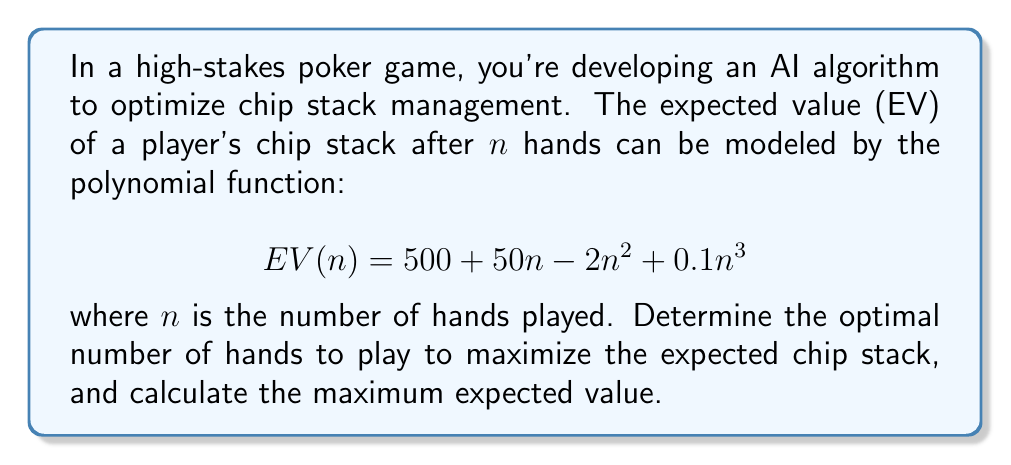Provide a solution to this math problem. To solve this optimization problem, we need to find the maximum of the polynomial function $EV(n)$. This can be done by finding the point where the first derivative of $EV(n)$ equals zero and the second derivative is negative.

1. First, let's find the first derivative of $EV(n)$:
   $$EV'(n) = 50 - 4n + 0.3n^2$$

2. Set the first derivative to zero and solve for n:
   $$50 - 4n + 0.3n^2 = 0$$
   $$0.3n^2 - 4n + 50 = 0$$

3. This is a quadratic equation. We can solve it using the quadratic formula:
   $$n = \frac{-b \pm \sqrt{b^2 - 4ac}}{2a}$$
   where $a = 0.3$, $b = -4$, and $c = 50$

4. Plugging in the values:
   $$n = \frac{4 \pm \sqrt{16 - 4(0.3)(50)}}{2(0.3)}$$
   $$n = \frac{4 \pm \sqrt{16 - 60}}{0.6}$$
   $$n = \frac{4 \pm \sqrt{-44}}{0.6}$$

5. Since we can't have a negative value under the square root, we need to consider the complex roots. However, in the context of our problem, we're only interested in the real, positive solution. The turning point occurs at the vertex of the parabola:

   $$n = -\frac{b}{2a} = -\frac{-4}{2(0.3)} = \frac{4}{0.6} \approx 6.67$$

6. Since we're dealing with a discrete number of hands, we round this to the nearest integer: 7 hands.

7. To confirm this is a maximum (not a minimum), we check the second derivative:
   $$EV''(n) = -4 + 0.6n$$
   At $n = 7$, $EV''(7) = -4 + 0.6(7) = 0.2 > 0$, confirming it's a maximum.

8. Calculate the maximum expected value by plugging n = 7 into the original function:
   $$EV(7) = 500 + 50(7) - 2(7^2) + 0.1(7^3)$$
   $$= 500 + 350 - 98 + 34.3$$
   $$= 786.3$$
Answer: The optimal number of hands to play is 7, and the maximum expected chip stack value is approximately 786.3 chips. 